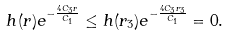<formula> <loc_0><loc_0><loc_500><loc_500>h ( r ) e ^ { - \frac { 4 C _ { 3 } r } { C _ { 1 } } } \leq h ( r _ { 3 } ) e ^ { - \frac { 4 C _ { 3 } r _ { 3 } } { C _ { 1 } } } = 0 .</formula> 